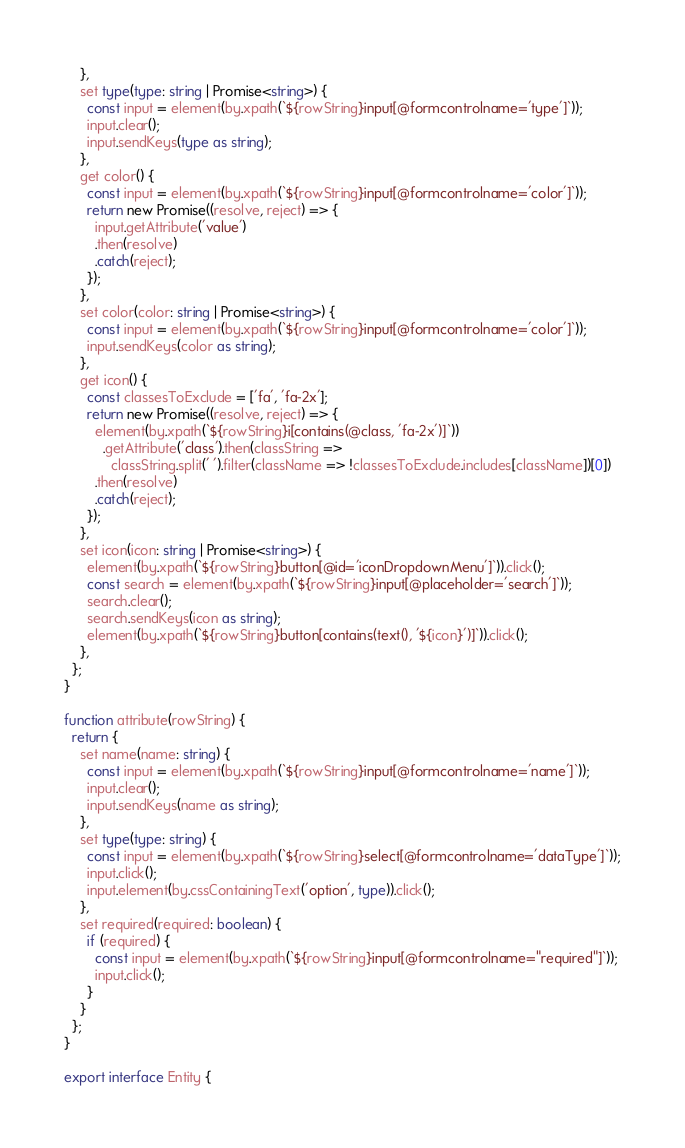Convert code to text. <code><loc_0><loc_0><loc_500><loc_500><_TypeScript_>    },
    set type(type: string | Promise<string>) {
      const input = element(by.xpath(`${rowString}input[@formcontrolname='type']`));
      input.clear();
      input.sendKeys(type as string);
    },
    get color() {
      const input = element(by.xpath(`${rowString}input[@formcontrolname='color']`));
      return new Promise((resolve, reject) => {
        input.getAttribute('value')
        .then(resolve)
        .catch(reject);
      });
    },
    set color(color: string | Promise<string>) {
      const input = element(by.xpath(`${rowString}input[@formcontrolname='color']`));
      input.sendKeys(color as string);
    },
    get icon() {
      const classesToExclude = ['fa', 'fa-2x'];
      return new Promise((resolve, reject) => {
        element(by.xpath(`${rowString}i[contains(@class, 'fa-2x')]`))
          .getAttribute('class').then(classString =>
            classString.split(' ').filter(className => !classesToExclude.includes[className])[0])
        .then(resolve)
        .catch(reject);
      });
    },
    set icon(icon: string | Promise<string>) {
      element(by.xpath(`${rowString}button[@id='iconDropdownMenu']`)).click();
      const search = element(by.xpath(`${rowString}input[@placeholder='search']`));
      search.clear();
      search.sendKeys(icon as string);
      element(by.xpath(`${rowString}button[contains(text(), '${icon}')]`)).click();
    },
  };
}

function attribute(rowString) {
  return {
    set name(name: string) {
      const input = element(by.xpath(`${rowString}input[@formcontrolname='name']`));
      input.clear();
      input.sendKeys(name as string);
    },
    set type(type: string) {
      const input = element(by.xpath(`${rowString}select[@formcontrolname='dataType']`));
      input.click();
      input.element(by.cssContainingText('option', type)).click();
    },
    set required(required: boolean) {
      if (required) {
        const input = element(by.xpath(`${rowString}input[@formcontrolname="required"]`));
        input.click();
      }
    }
  };
}

export interface Entity {</code> 